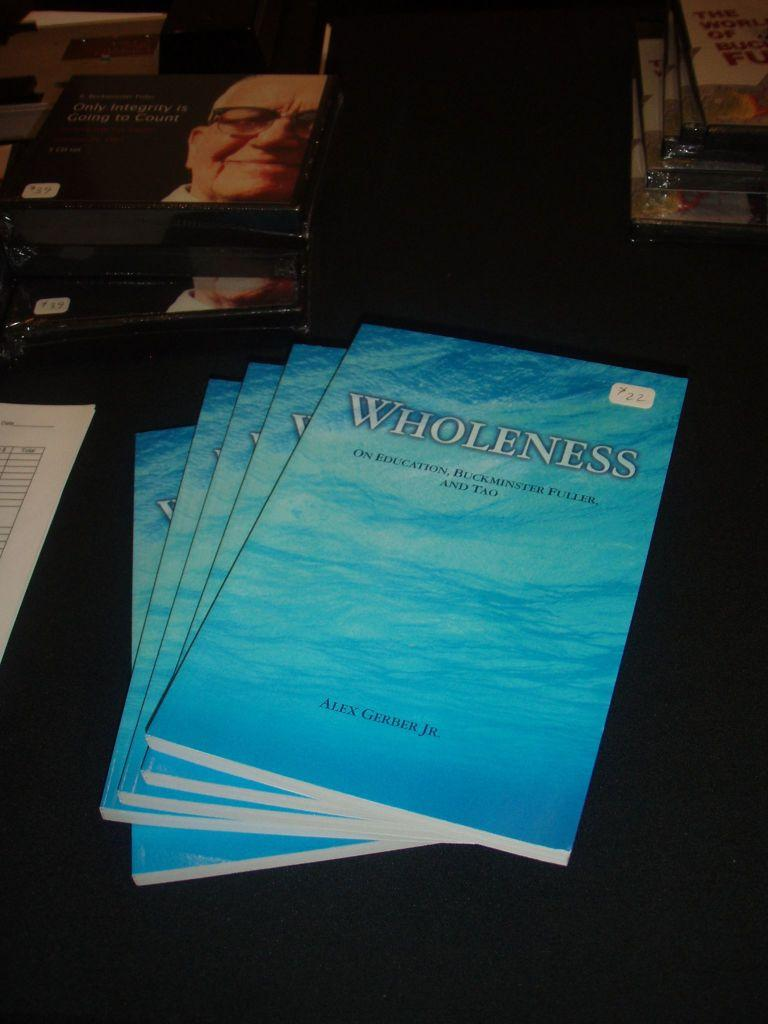Provide a one-sentence caption for the provided image. A stack of books are on a table and are titled Wholeness. 